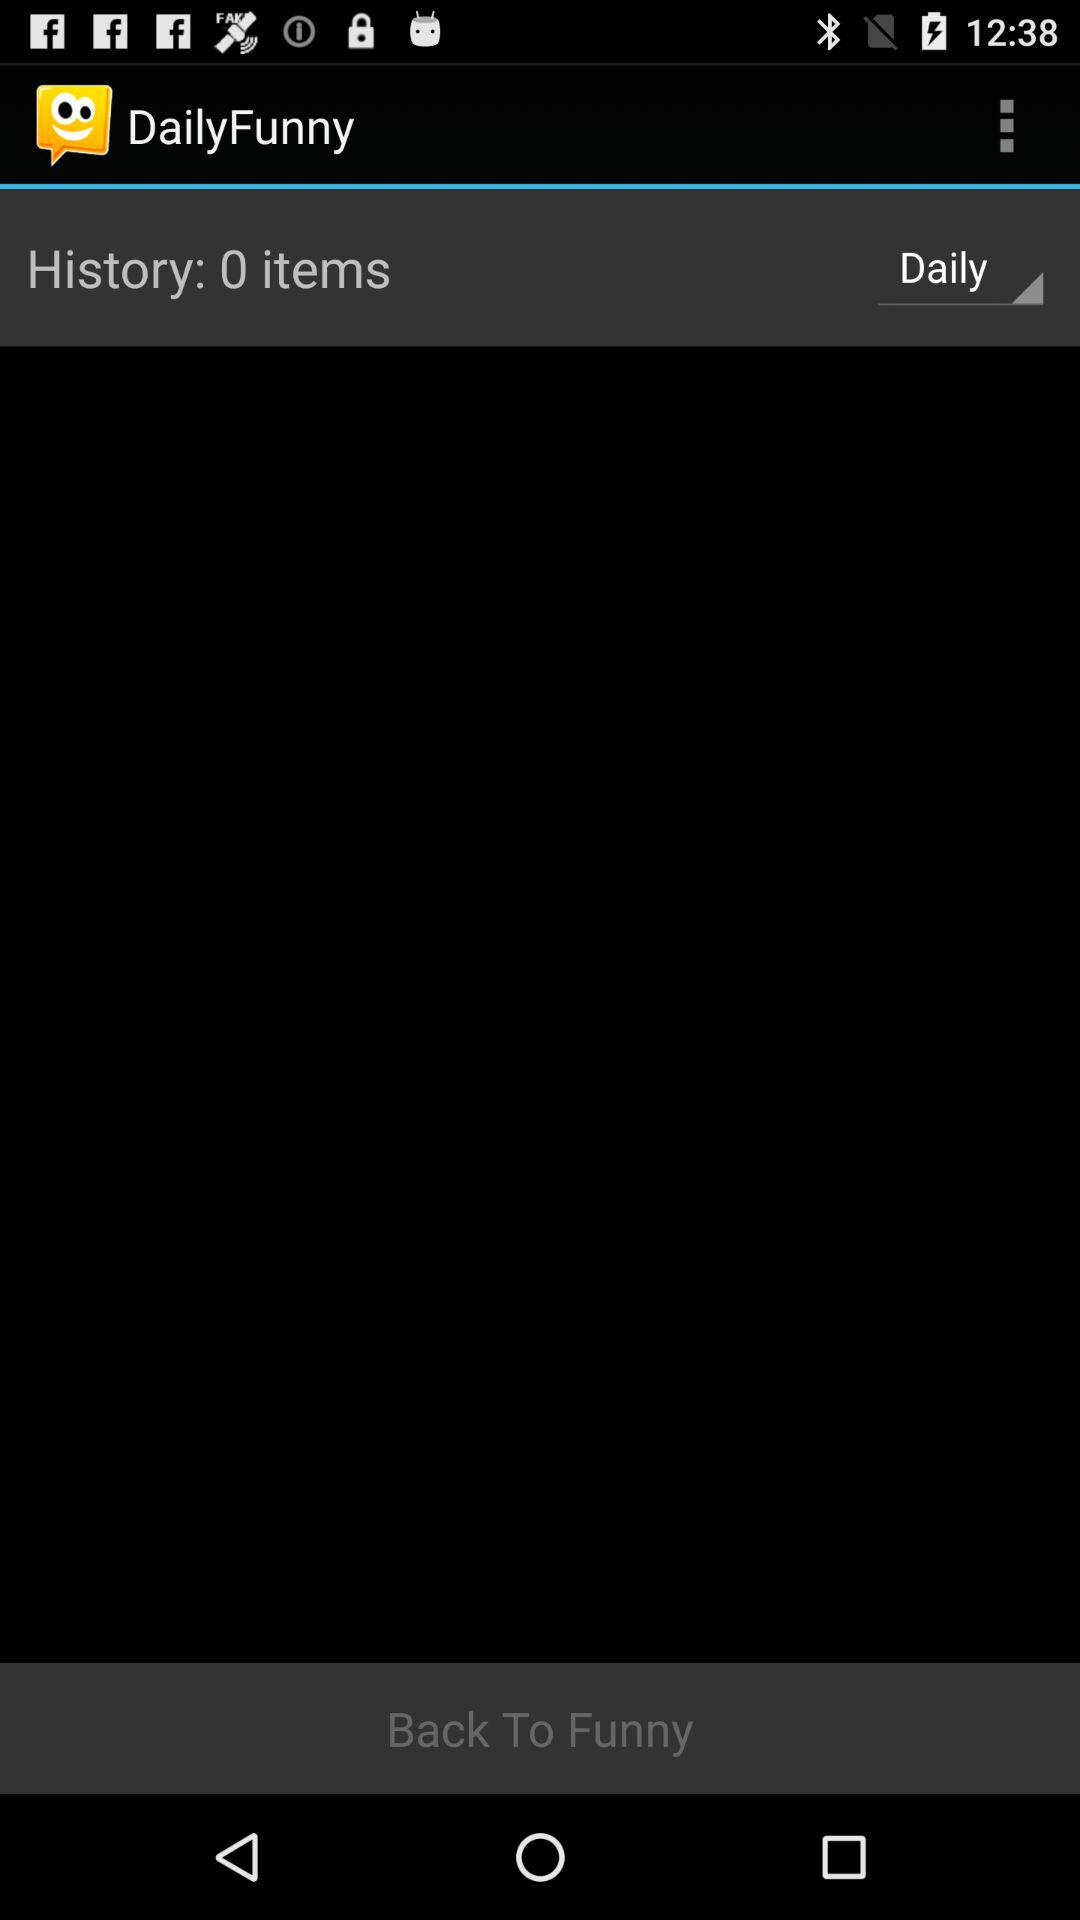How many items are there in history? There are 0 items in history. 